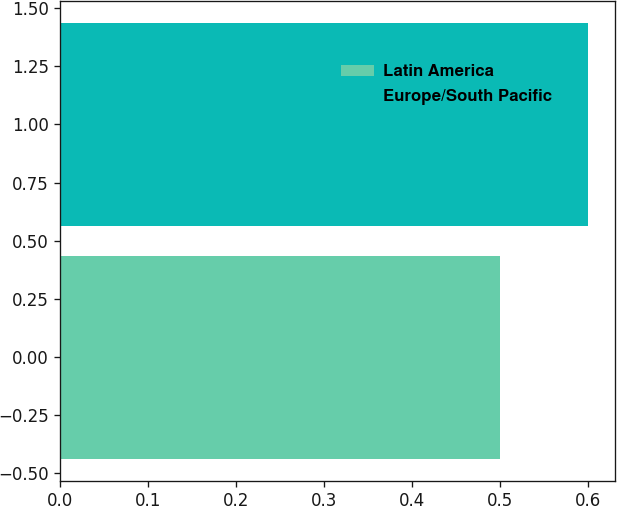Convert chart to OTSL. <chart><loc_0><loc_0><loc_500><loc_500><bar_chart><fcel>Latin America<fcel>Europe/South Pacific<nl><fcel>0.5<fcel>0.6<nl></chart> 